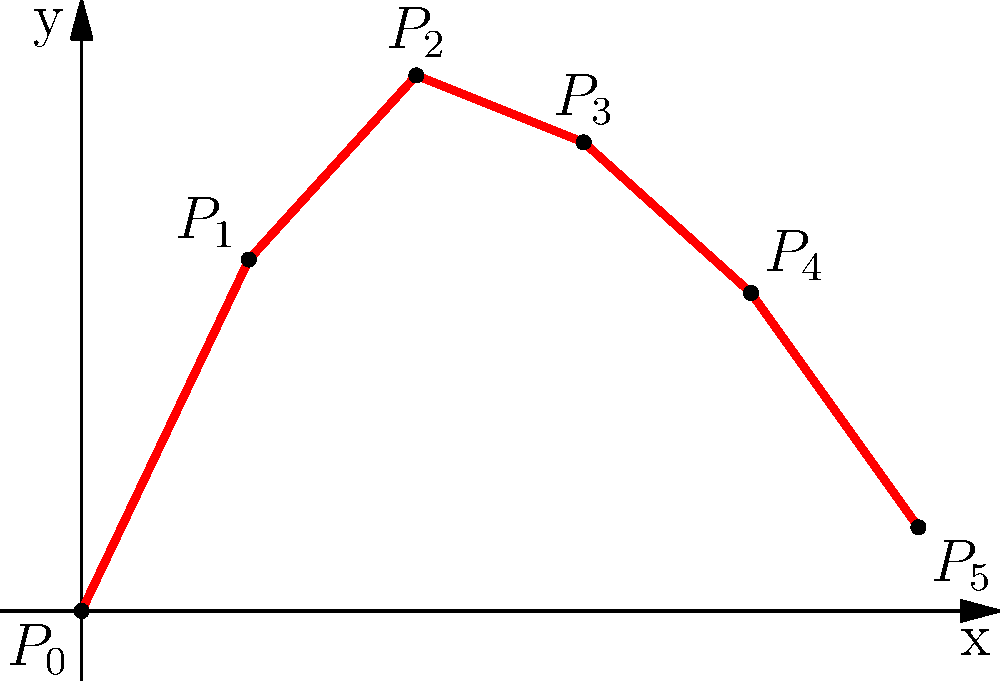You are trying to recreate the shape of a lost family cameo using polynomial interpolation. Given the points $(0,0)$, $(1,2.1)$, $(2,3.2)$, $(3,2.8)$, $(4,1.9)$, and $(5,0.5)$ representing key features of the cameo's profile, what degree polynomial would be required to exactly fit these points? To determine the degree of the polynomial needed to fit the given points exactly, we can follow these steps:

1. Count the number of points given: There are 6 points $(0,0)$, $(1,2.1)$, $(2,3.2)$, $(3,2.8)$, $(4,1.9)$, and $(5,0.5)$.

2. Apply the theorem for polynomial interpolation: For $n$ distinct points, there exists a unique polynomial of degree at most $n-1$ that passes through all the points.

3. Calculate the degree:
   - Number of points = 6
   - Degree of polynomial = (Number of points) - 1
   - Degree of polynomial = 6 - 1 = 5

Therefore, a 5th-degree polynomial (quintic polynomial) would be required to fit these points exactly.

The general form of a 5th-degree polynomial is:

$$ f(x) = ax^5 + bx^4 + cx^3 + dx^2 + ex + f $$

where $a$, $b$, $c$, $d$, $e$, and $f$ are constants that would be determined by solving a system of equations using the given points.
Answer: 5th degree (quintic) polynomial 